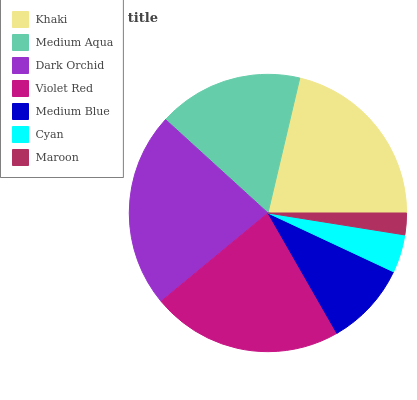Is Maroon the minimum?
Answer yes or no. Yes. Is Dark Orchid the maximum?
Answer yes or no. Yes. Is Medium Aqua the minimum?
Answer yes or no. No. Is Medium Aqua the maximum?
Answer yes or no. No. Is Khaki greater than Medium Aqua?
Answer yes or no. Yes. Is Medium Aqua less than Khaki?
Answer yes or no. Yes. Is Medium Aqua greater than Khaki?
Answer yes or no. No. Is Khaki less than Medium Aqua?
Answer yes or no. No. Is Medium Aqua the high median?
Answer yes or no. Yes. Is Medium Aqua the low median?
Answer yes or no. Yes. Is Maroon the high median?
Answer yes or no. No. Is Medium Blue the low median?
Answer yes or no. No. 